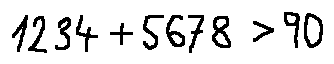<formula> <loc_0><loc_0><loc_500><loc_500>1 2 3 4 + 5 6 7 8 > 9 0</formula> 